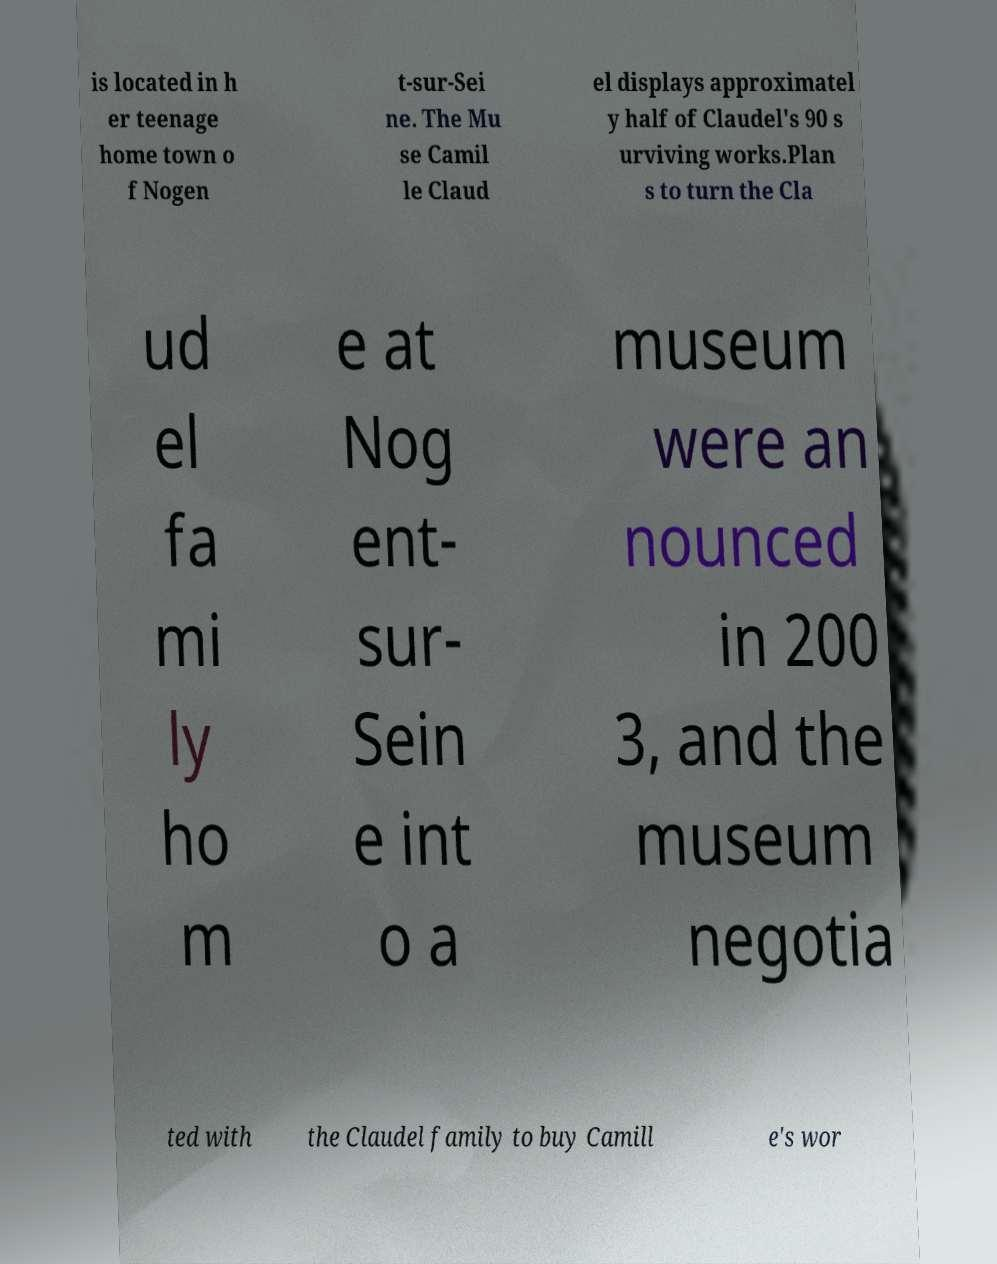Could you assist in decoding the text presented in this image and type it out clearly? is located in h er teenage home town o f Nogen t-sur-Sei ne. The Mu se Camil le Claud el displays approximatel y half of Claudel's 90 s urviving works.Plan s to turn the Cla ud el fa mi ly ho m e at Nog ent- sur- Sein e int o a museum were an nounced in 200 3, and the museum negotia ted with the Claudel family to buy Camill e's wor 